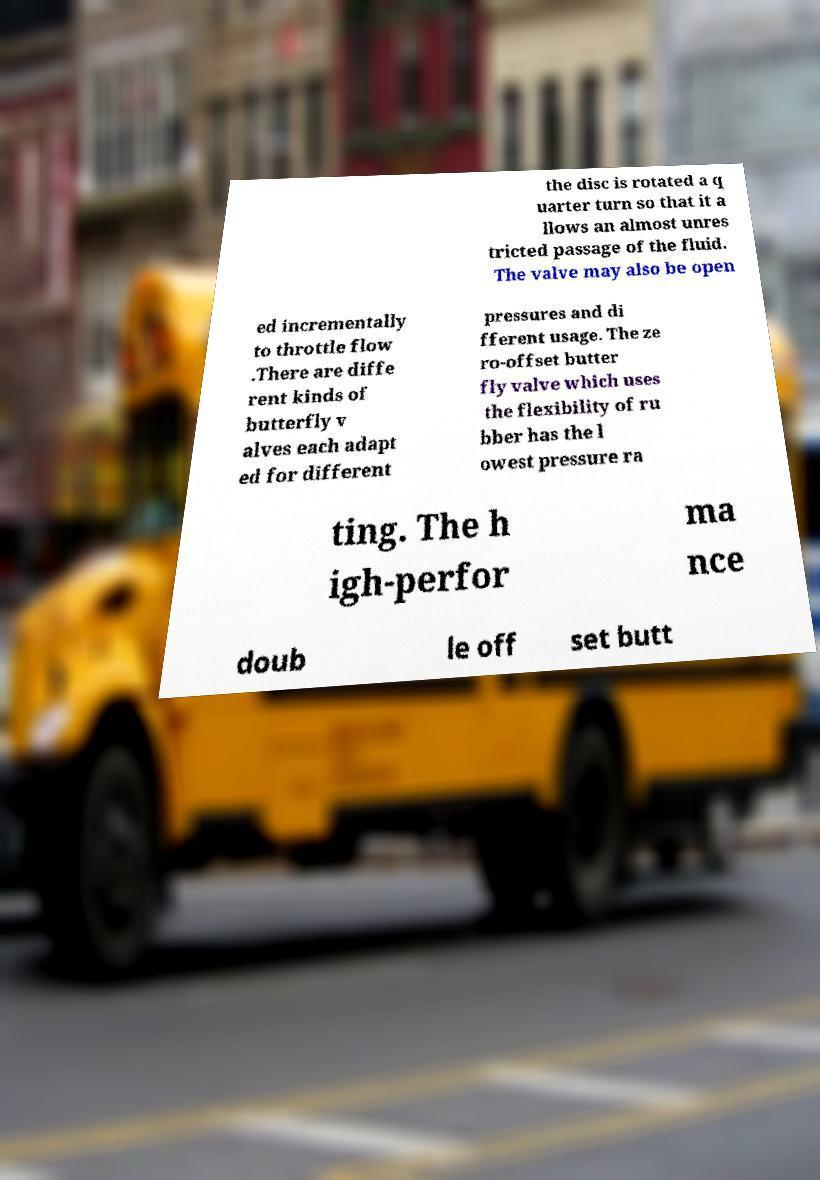What messages or text are displayed in this image? I need them in a readable, typed format. the disc is rotated a q uarter turn so that it a llows an almost unres tricted passage of the fluid. The valve may also be open ed incrementally to throttle flow .There are diffe rent kinds of butterfly v alves each adapt ed for different pressures and di fferent usage. The ze ro-offset butter fly valve which uses the flexibility of ru bber has the l owest pressure ra ting. The h igh-perfor ma nce doub le off set butt 